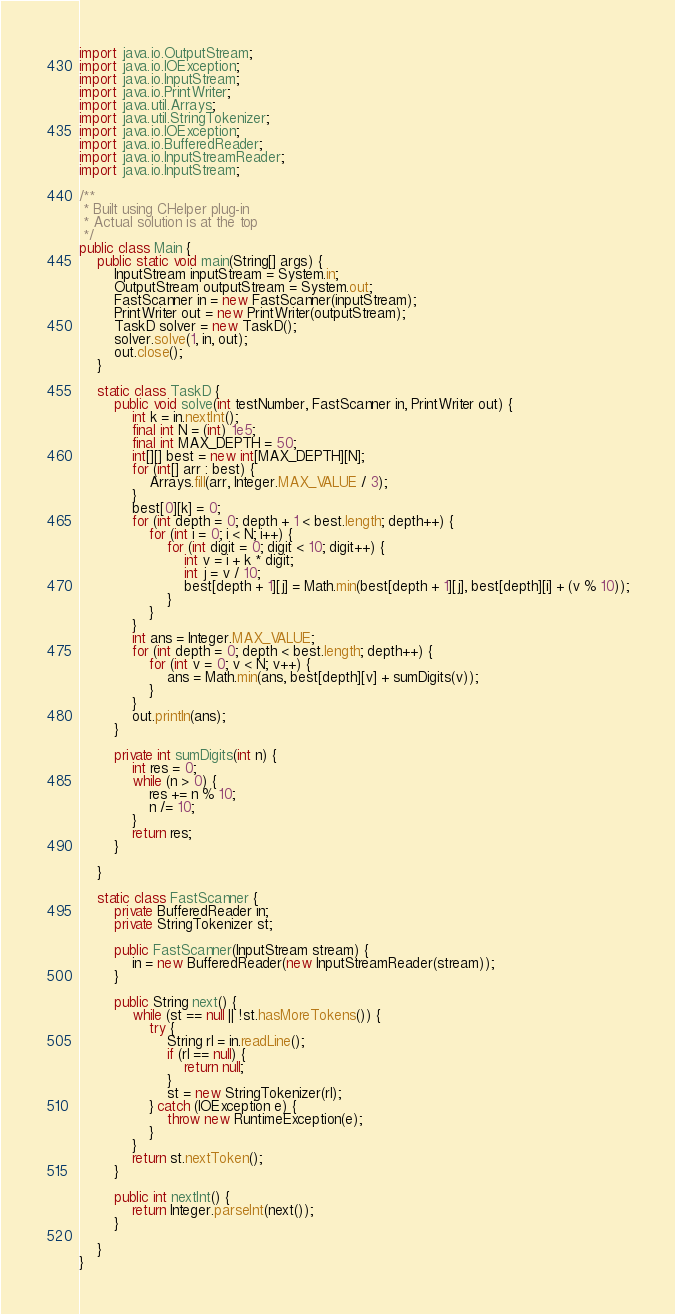Convert code to text. <code><loc_0><loc_0><loc_500><loc_500><_Java_>import java.io.OutputStream;
import java.io.IOException;
import java.io.InputStream;
import java.io.PrintWriter;
import java.util.Arrays;
import java.util.StringTokenizer;
import java.io.IOException;
import java.io.BufferedReader;
import java.io.InputStreamReader;
import java.io.InputStream;

/**
 * Built using CHelper plug-in
 * Actual solution is at the top
 */
public class Main {
	public static void main(String[] args) {
		InputStream inputStream = System.in;
		OutputStream outputStream = System.out;
		FastScanner in = new FastScanner(inputStream);
		PrintWriter out = new PrintWriter(outputStream);
		TaskD solver = new TaskD();
		solver.solve(1, in, out);
		out.close();
	}

	static class TaskD {
		public void solve(int testNumber, FastScanner in, PrintWriter out) {
			int k = in.nextInt();
			final int N = (int) 1e5;
			final int MAX_DEPTH = 50;
			int[][] best = new int[MAX_DEPTH][N];
			for (int[] arr : best) {
				Arrays.fill(arr, Integer.MAX_VALUE / 3);
			}
			best[0][k] = 0;
			for (int depth = 0; depth + 1 < best.length; depth++) {
				for (int i = 0; i < N; i++) {
					for (int digit = 0; digit < 10; digit++) {
						int v = i + k * digit;
						int j = v / 10;
						best[depth + 1][j] = Math.min(best[depth + 1][j], best[depth][i] + (v % 10));
					}
				}
			}
			int ans = Integer.MAX_VALUE;
			for (int depth = 0; depth < best.length; depth++) {
				for (int v = 0; v < N; v++) {
					ans = Math.min(ans, best[depth][v] + sumDigits(v));
				}
			}
			out.println(ans);
		}

		private int sumDigits(int n) {
			int res = 0;
			while (n > 0) {
				res += n % 10;
				n /= 10;
			}
			return res;
		}

	}

	static class FastScanner {
		private BufferedReader in;
		private StringTokenizer st;

		public FastScanner(InputStream stream) {
			in = new BufferedReader(new InputStreamReader(stream));
		}

		public String next() {
			while (st == null || !st.hasMoreTokens()) {
				try {
					String rl = in.readLine();
					if (rl == null) {
						return null;
					}
					st = new StringTokenizer(rl);
				} catch (IOException e) {
					throw new RuntimeException(e);
				}
			}
			return st.nextToken();
		}

		public int nextInt() {
			return Integer.parseInt(next());
		}

	}
}

</code> 